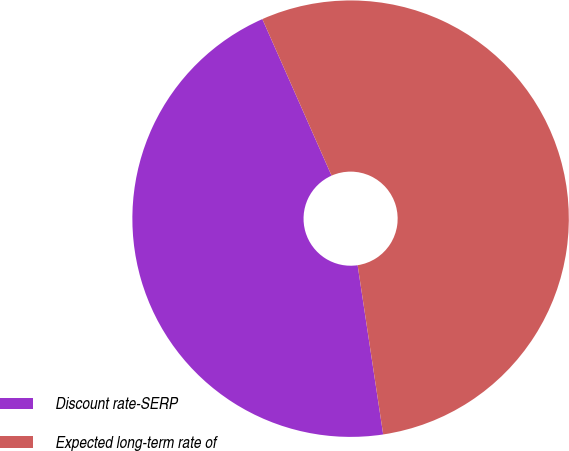<chart> <loc_0><loc_0><loc_500><loc_500><pie_chart><fcel>Discount rate-SERP<fcel>Expected long-term rate of<nl><fcel>45.76%<fcel>54.24%<nl></chart> 